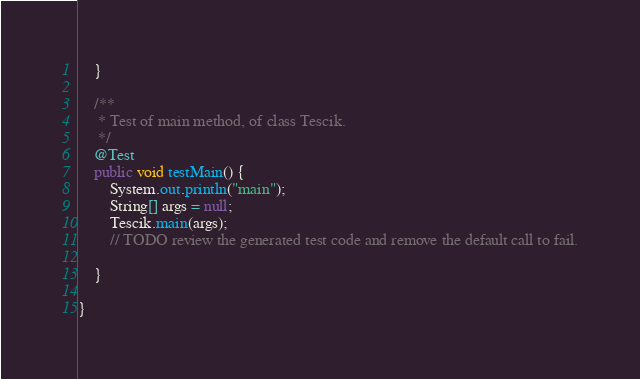<code> <loc_0><loc_0><loc_500><loc_500><_Java_>    }

    /**
     * Test of main method, of class Tescik.
     */
    @Test
    public void testMain() {
        System.out.println("main");
        String[] args = null;
        Tescik.main(args);
        // TODO review the generated test code and remove the default call to fail.
        
    }
    
}
</code> 